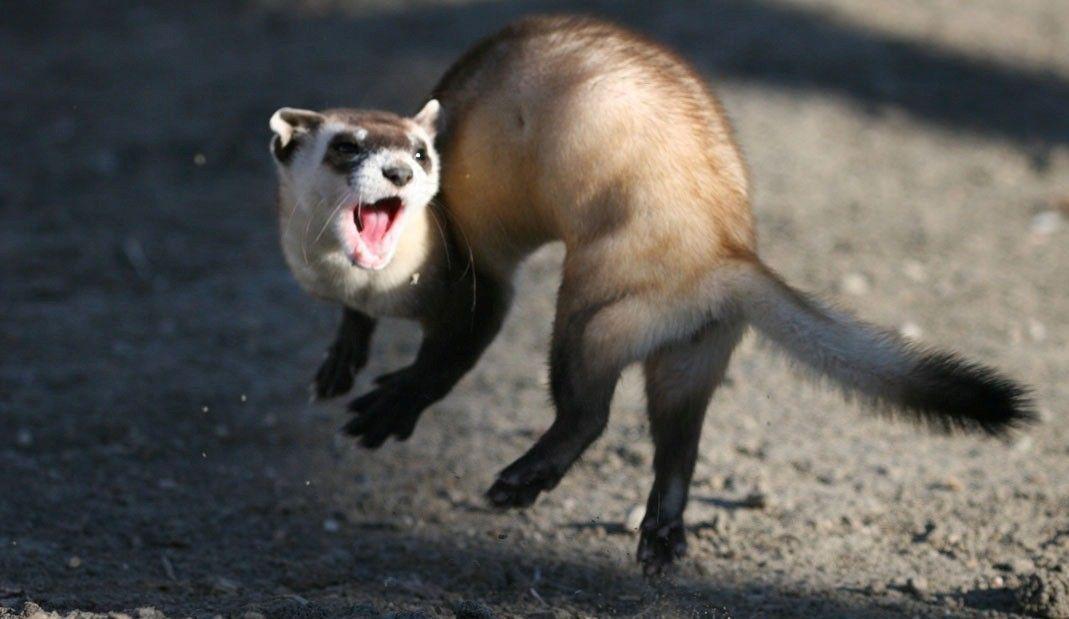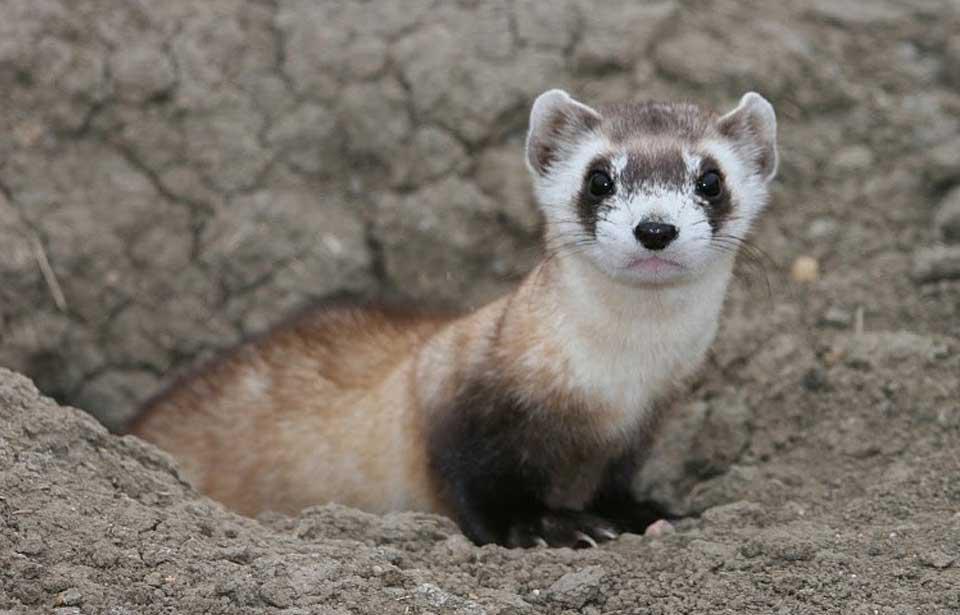The first image is the image on the left, the second image is the image on the right. Examine the images to the left and right. Is the description "One image shows a single ferret with all its feet off the ground and its face forward." accurate? Answer yes or no. Yes. 